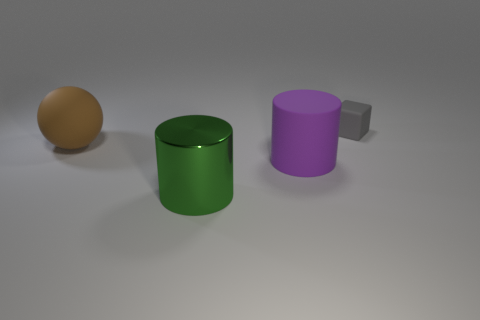Add 3 large rubber things. How many objects exist? 7 Subtract all cubes. How many objects are left? 3 Subtract all blue matte cylinders. Subtract all large things. How many objects are left? 1 Add 2 purple things. How many purple things are left? 3 Add 3 tiny brown matte blocks. How many tiny brown matte blocks exist? 3 Subtract 0 yellow spheres. How many objects are left? 4 